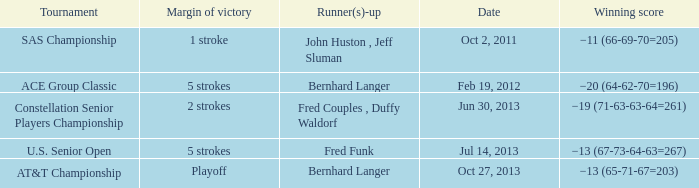Which Tournament has a Date of jul 14, 2013? U.S. Senior Open. Would you be able to parse every entry in this table? {'header': ['Tournament', 'Margin of victory', 'Runner(s)-up', 'Date', 'Winning score'], 'rows': [['SAS Championship', '1 stroke', 'John Huston , Jeff Sluman', 'Oct 2, 2011', '−11 (66-69-70=205)'], ['ACE Group Classic', '5 strokes', 'Bernhard Langer', 'Feb 19, 2012', '−20 (64-62-70=196)'], ['Constellation Senior Players Championship', '2 strokes', 'Fred Couples , Duffy Waldorf', 'Jun 30, 2013', '−19 (71-63-63-64=261)'], ['U.S. Senior Open', '5 strokes', 'Fred Funk', 'Jul 14, 2013', '−13 (67-73-64-63=267)'], ['AT&T Championship', 'Playoff', 'Bernhard Langer', 'Oct 27, 2013', '−13 (65-71-67=203)']]} 